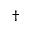<formula> <loc_0><loc_0><loc_500><loc_500>^ { \dag }</formula> 